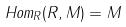Convert formula to latex. <formula><loc_0><loc_0><loc_500><loc_500>H o m _ { R } ( R , M ) = M</formula> 